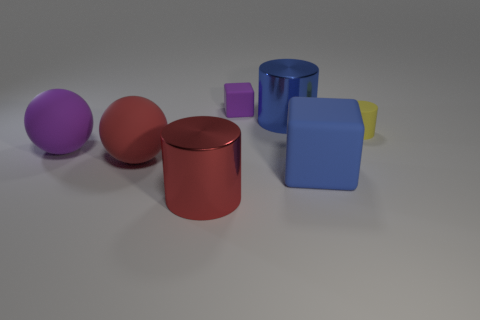Add 3 small yellow things. How many objects exist? 10 Subtract all spheres. How many objects are left? 5 Subtract all tiny green shiny balls. Subtract all purple matte spheres. How many objects are left? 6 Add 5 small yellow matte cylinders. How many small yellow matte cylinders are left? 6 Add 4 large red matte spheres. How many large red matte spheres exist? 5 Subtract 0 green cylinders. How many objects are left? 7 